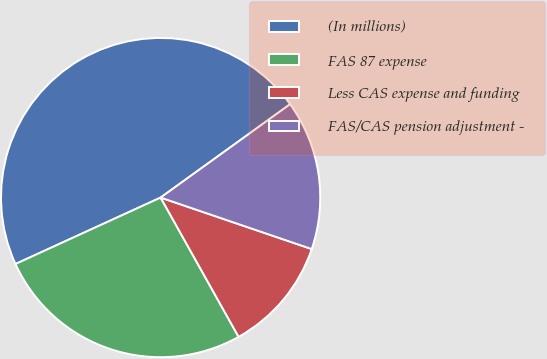Convert chart to OTSL. <chart><loc_0><loc_0><loc_500><loc_500><pie_chart><fcel>(In millions)<fcel>FAS 87 expense<fcel>Less CAS expense and funding<fcel>FAS/CAS pension adjustment -<nl><fcel>46.89%<fcel>26.29%<fcel>11.65%<fcel>15.17%<nl></chart> 